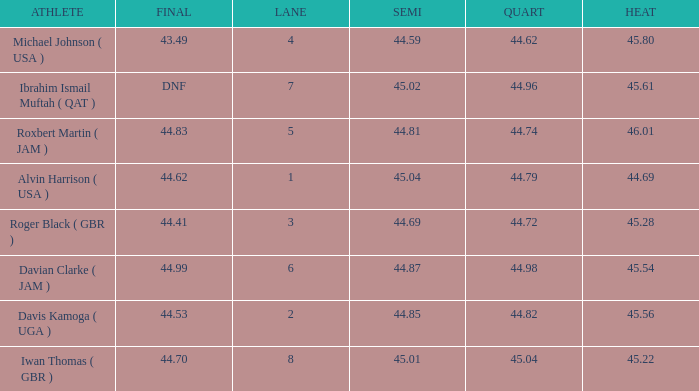When a lane of 4 has a QUART greater than 44.62, what is the lowest HEAT? None. 